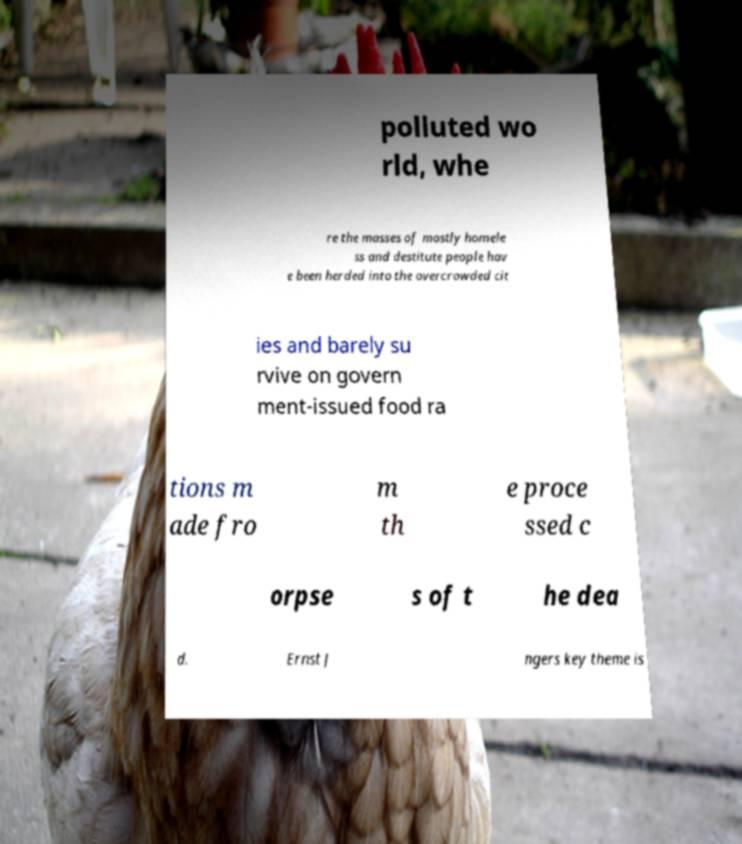What messages or text are displayed in this image? I need them in a readable, typed format. polluted wo rld, whe re the masses of mostly homele ss and destitute people hav e been herded into the overcrowded cit ies and barely su rvive on govern ment-issued food ra tions m ade fro m th e proce ssed c orpse s of t he dea d. Ernst J ngers key theme is 